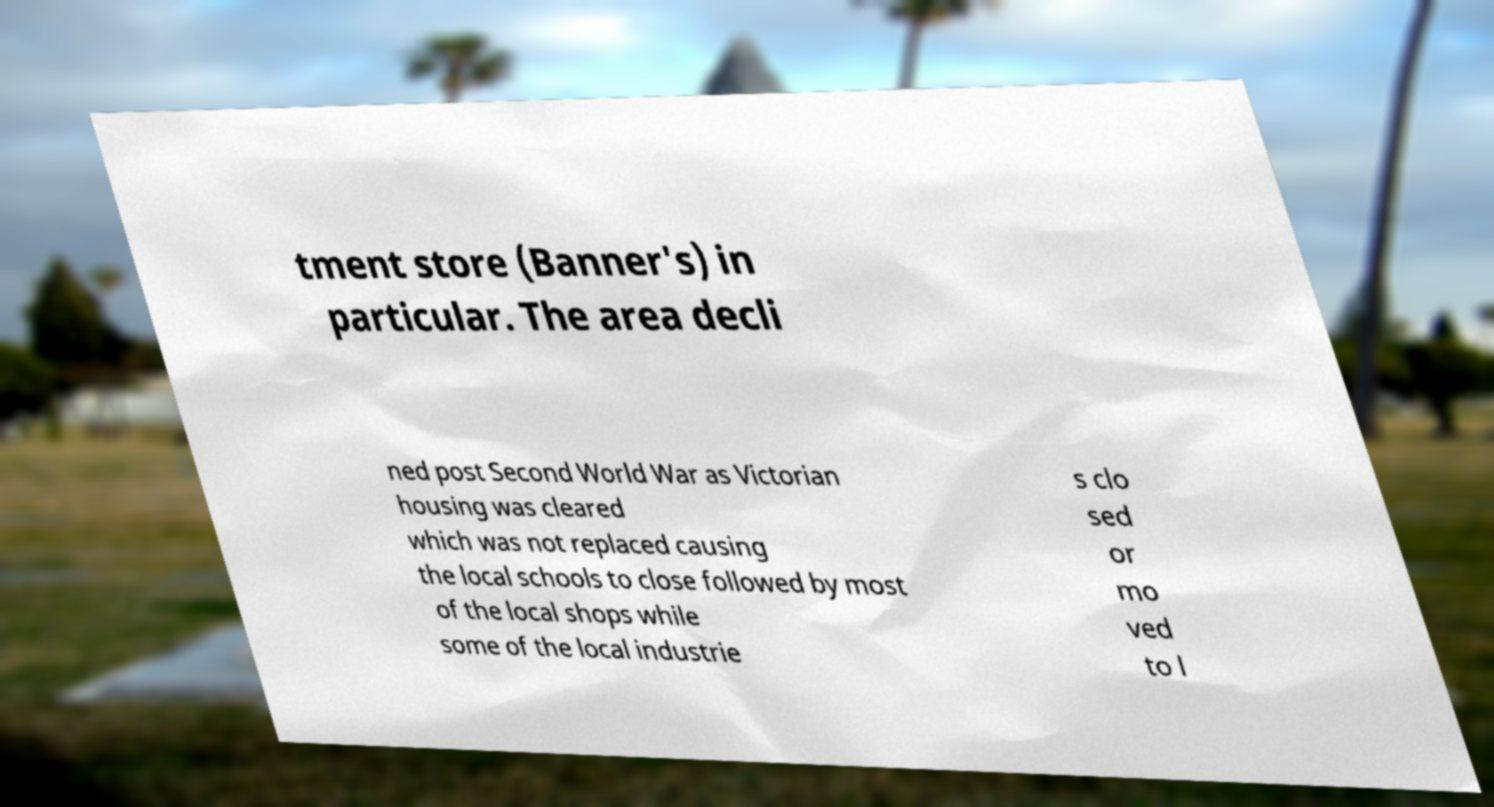Can you read and provide the text displayed in the image?This photo seems to have some interesting text. Can you extract and type it out for me? tment store (Banner's) in particular. The area decli ned post Second World War as Victorian housing was cleared which was not replaced causing the local schools to close followed by most of the local shops while some of the local industrie s clo sed or mo ved to l 